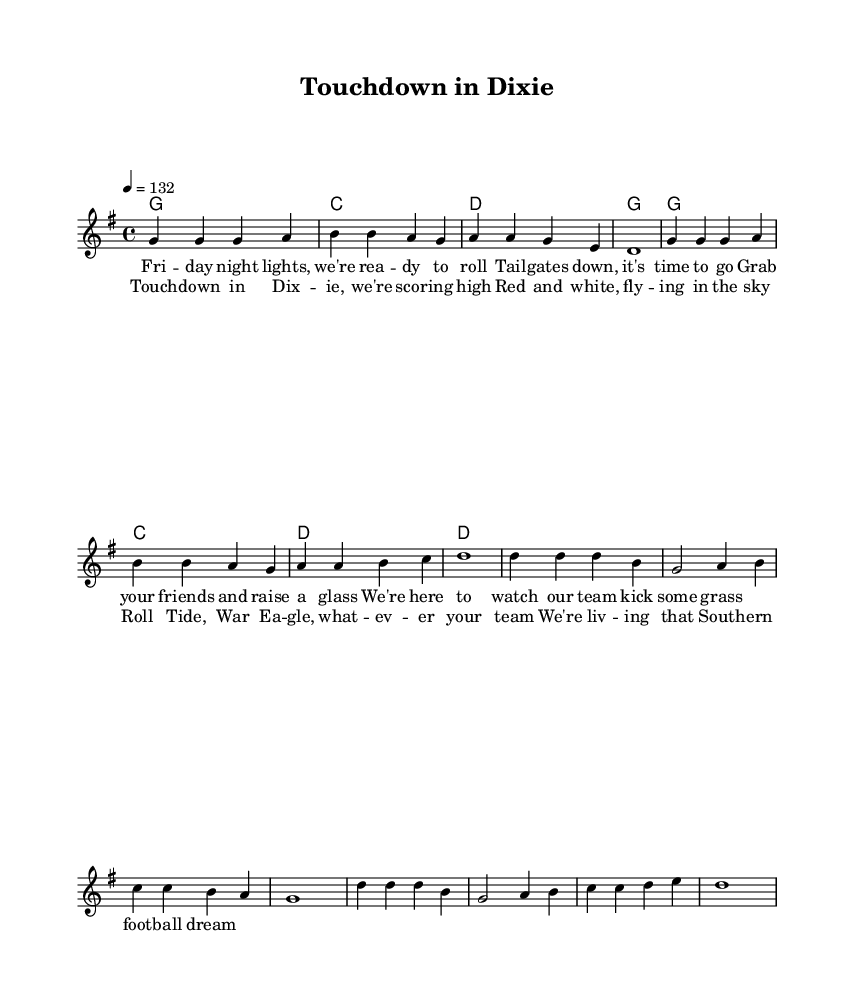What is the key signature of this music? The key signature is G major, indicated by one sharp (F#) at the beginning of the sheet music.
Answer: G major What is the time signature of this music? The time signature shown in the music is 4/4, which is commonly used in upbeat and danceable music such as country-rock anthems.
Answer: 4/4 What is the tempo marking of this music? The tempo is marked as 4 = 132, which means there are 132 beats per minute, indicating a lively pace suitable for tailgating and football games.
Answer: 132 What is the overall dynamic of the chorus? The chorus suggests a strong and lively dynamic, suitable for anthemic singing, as implied by the ascending notes and the energetic lyrics calling for team spirit.
Answer: Energetic How many measures are in the verse section? The verse consists of 8 measures, which can be counted by looking at the bar lines separating each measure in the melody section.
Answer: 8 measures In which part of the song are team spirit and camaraderie emphasized? The chorus emphasizes team spirit and camaraderie, especially with the repeated references to teams and the energetic line "We're living that Southern football dream."
Answer: Chorus 